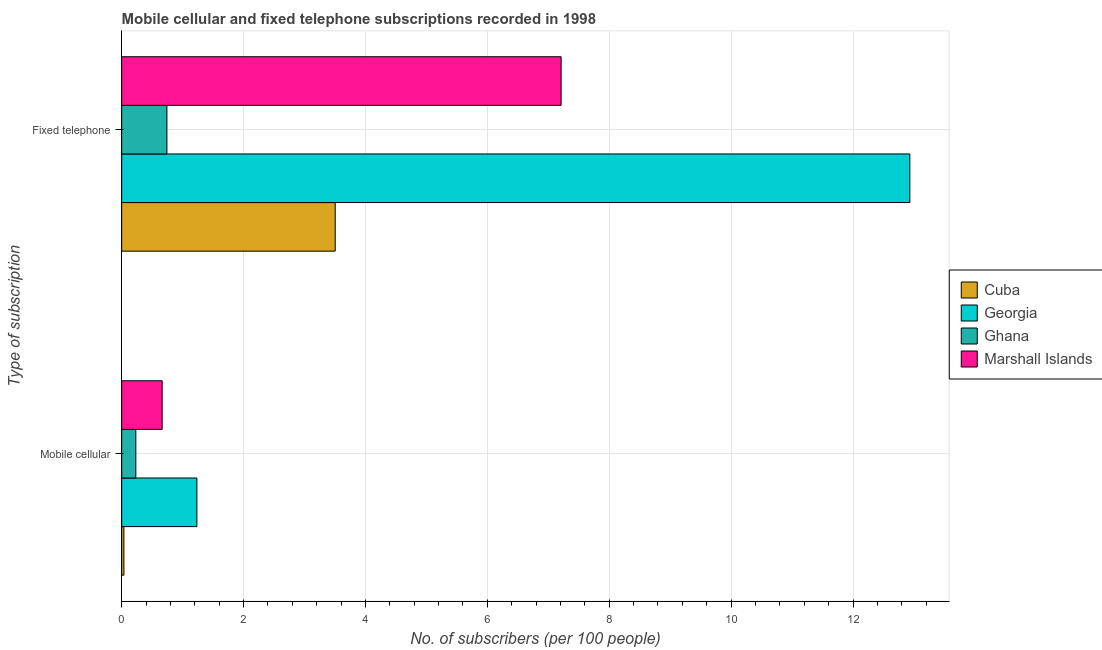How many groups of bars are there?
Your answer should be very brief. 2. Are the number of bars per tick equal to the number of legend labels?
Offer a terse response. Yes. Are the number of bars on each tick of the Y-axis equal?
Make the answer very short. Yes. How many bars are there on the 2nd tick from the top?
Provide a short and direct response. 4. What is the label of the 2nd group of bars from the top?
Make the answer very short. Mobile cellular. What is the number of mobile cellular subscribers in Cuba?
Give a very brief answer. 0.04. Across all countries, what is the maximum number of fixed telephone subscribers?
Ensure brevity in your answer.  12.93. Across all countries, what is the minimum number of fixed telephone subscribers?
Your answer should be very brief. 0.74. In which country was the number of fixed telephone subscribers maximum?
Make the answer very short. Georgia. In which country was the number of fixed telephone subscribers minimum?
Your answer should be very brief. Ghana. What is the total number of fixed telephone subscribers in the graph?
Offer a terse response. 24.39. What is the difference between the number of mobile cellular subscribers in Ghana and that in Marshall Islands?
Offer a very short reply. -0.43. What is the difference between the number of fixed telephone subscribers in Cuba and the number of mobile cellular subscribers in Ghana?
Your answer should be very brief. 3.27. What is the average number of mobile cellular subscribers per country?
Provide a short and direct response. 0.54. What is the difference between the number of fixed telephone subscribers and number of mobile cellular subscribers in Marshall Islands?
Provide a short and direct response. 6.55. What is the ratio of the number of mobile cellular subscribers in Cuba to that in Ghana?
Offer a very short reply. 0.16. Is the number of mobile cellular subscribers in Georgia less than that in Cuba?
Make the answer very short. No. In how many countries, is the number of mobile cellular subscribers greater than the average number of mobile cellular subscribers taken over all countries?
Make the answer very short. 2. What does the 4th bar from the top in Mobile cellular represents?
Provide a succinct answer. Cuba. What does the 1st bar from the bottom in Mobile cellular represents?
Provide a short and direct response. Cuba. How many bars are there?
Provide a succinct answer. 8. What is the difference between two consecutive major ticks on the X-axis?
Provide a short and direct response. 2. Are the values on the major ticks of X-axis written in scientific E-notation?
Your answer should be very brief. No. Does the graph contain grids?
Give a very brief answer. Yes. How many legend labels are there?
Offer a terse response. 4. What is the title of the graph?
Offer a terse response. Mobile cellular and fixed telephone subscriptions recorded in 1998. What is the label or title of the X-axis?
Ensure brevity in your answer.  No. of subscribers (per 100 people). What is the label or title of the Y-axis?
Offer a very short reply. Type of subscription. What is the No. of subscribers (per 100 people) of Cuba in Mobile cellular?
Keep it short and to the point. 0.04. What is the No. of subscribers (per 100 people) in Georgia in Mobile cellular?
Give a very brief answer. 1.23. What is the No. of subscribers (per 100 people) of Ghana in Mobile cellular?
Make the answer very short. 0.23. What is the No. of subscribers (per 100 people) in Marshall Islands in Mobile cellular?
Ensure brevity in your answer.  0.66. What is the No. of subscribers (per 100 people) of Cuba in Fixed telephone?
Provide a short and direct response. 3.5. What is the No. of subscribers (per 100 people) of Georgia in Fixed telephone?
Keep it short and to the point. 12.93. What is the No. of subscribers (per 100 people) in Ghana in Fixed telephone?
Make the answer very short. 0.74. What is the No. of subscribers (per 100 people) in Marshall Islands in Fixed telephone?
Your response must be concise. 7.21. Across all Type of subscription, what is the maximum No. of subscribers (per 100 people) in Cuba?
Your answer should be very brief. 3.5. Across all Type of subscription, what is the maximum No. of subscribers (per 100 people) of Georgia?
Ensure brevity in your answer.  12.93. Across all Type of subscription, what is the maximum No. of subscribers (per 100 people) in Ghana?
Your response must be concise. 0.74. Across all Type of subscription, what is the maximum No. of subscribers (per 100 people) of Marshall Islands?
Your answer should be compact. 7.21. Across all Type of subscription, what is the minimum No. of subscribers (per 100 people) of Cuba?
Give a very brief answer. 0.04. Across all Type of subscription, what is the minimum No. of subscribers (per 100 people) of Georgia?
Keep it short and to the point. 1.23. Across all Type of subscription, what is the minimum No. of subscribers (per 100 people) of Ghana?
Your answer should be very brief. 0.23. Across all Type of subscription, what is the minimum No. of subscribers (per 100 people) in Marshall Islands?
Offer a very short reply. 0.66. What is the total No. of subscribers (per 100 people) of Cuba in the graph?
Ensure brevity in your answer.  3.54. What is the total No. of subscribers (per 100 people) in Georgia in the graph?
Provide a succinct answer. 14.17. What is the total No. of subscribers (per 100 people) of Ghana in the graph?
Your answer should be very brief. 0.97. What is the total No. of subscribers (per 100 people) of Marshall Islands in the graph?
Your response must be concise. 7.88. What is the difference between the No. of subscribers (per 100 people) in Cuba in Mobile cellular and that in Fixed telephone?
Provide a short and direct response. -3.47. What is the difference between the No. of subscribers (per 100 people) in Georgia in Mobile cellular and that in Fixed telephone?
Offer a very short reply. -11.7. What is the difference between the No. of subscribers (per 100 people) in Ghana in Mobile cellular and that in Fixed telephone?
Your answer should be compact. -0.51. What is the difference between the No. of subscribers (per 100 people) of Marshall Islands in Mobile cellular and that in Fixed telephone?
Your answer should be very brief. -6.55. What is the difference between the No. of subscribers (per 100 people) of Cuba in Mobile cellular and the No. of subscribers (per 100 people) of Georgia in Fixed telephone?
Offer a terse response. -12.9. What is the difference between the No. of subscribers (per 100 people) of Cuba in Mobile cellular and the No. of subscribers (per 100 people) of Ghana in Fixed telephone?
Your answer should be very brief. -0.71. What is the difference between the No. of subscribers (per 100 people) of Cuba in Mobile cellular and the No. of subscribers (per 100 people) of Marshall Islands in Fixed telephone?
Provide a short and direct response. -7.17. What is the difference between the No. of subscribers (per 100 people) of Georgia in Mobile cellular and the No. of subscribers (per 100 people) of Ghana in Fixed telephone?
Ensure brevity in your answer.  0.49. What is the difference between the No. of subscribers (per 100 people) in Georgia in Mobile cellular and the No. of subscribers (per 100 people) in Marshall Islands in Fixed telephone?
Keep it short and to the point. -5.98. What is the difference between the No. of subscribers (per 100 people) in Ghana in Mobile cellular and the No. of subscribers (per 100 people) in Marshall Islands in Fixed telephone?
Make the answer very short. -6.98. What is the average No. of subscribers (per 100 people) of Cuba per Type of subscription?
Offer a very short reply. 1.77. What is the average No. of subscribers (per 100 people) in Georgia per Type of subscription?
Offer a terse response. 7.08. What is the average No. of subscribers (per 100 people) in Ghana per Type of subscription?
Offer a very short reply. 0.49. What is the average No. of subscribers (per 100 people) in Marshall Islands per Type of subscription?
Make the answer very short. 3.94. What is the difference between the No. of subscribers (per 100 people) in Cuba and No. of subscribers (per 100 people) in Georgia in Mobile cellular?
Your answer should be compact. -1.2. What is the difference between the No. of subscribers (per 100 people) in Cuba and No. of subscribers (per 100 people) in Ghana in Mobile cellular?
Offer a very short reply. -0.2. What is the difference between the No. of subscribers (per 100 people) of Cuba and No. of subscribers (per 100 people) of Marshall Islands in Mobile cellular?
Offer a very short reply. -0.63. What is the difference between the No. of subscribers (per 100 people) in Georgia and No. of subscribers (per 100 people) in Ghana in Mobile cellular?
Offer a terse response. 1. What is the difference between the No. of subscribers (per 100 people) in Georgia and No. of subscribers (per 100 people) in Marshall Islands in Mobile cellular?
Provide a succinct answer. 0.57. What is the difference between the No. of subscribers (per 100 people) of Ghana and No. of subscribers (per 100 people) of Marshall Islands in Mobile cellular?
Ensure brevity in your answer.  -0.43. What is the difference between the No. of subscribers (per 100 people) of Cuba and No. of subscribers (per 100 people) of Georgia in Fixed telephone?
Offer a very short reply. -9.43. What is the difference between the No. of subscribers (per 100 people) in Cuba and No. of subscribers (per 100 people) in Ghana in Fixed telephone?
Your answer should be compact. 2.76. What is the difference between the No. of subscribers (per 100 people) in Cuba and No. of subscribers (per 100 people) in Marshall Islands in Fixed telephone?
Make the answer very short. -3.71. What is the difference between the No. of subscribers (per 100 people) of Georgia and No. of subscribers (per 100 people) of Ghana in Fixed telephone?
Ensure brevity in your answer.  12.19. What is the difference between the No. of subscribers (per 100 people) in Georgia and No. of subscribers (per 100 people) in Marshall Islands in Fixed telephone?
Keep it short and to the point. 5.72. What is the difference between the No. of subscribers (per 100 people) in Ghana and No. of subscribers (per 100 people) in Marshall Islands in Fixed telephone?
Ensure brevity in your answer.  -6.47. What is the ratio of the No. of subscribers (per 100 people) of Cuba in Mobile cellular to that in Fixed telephone?
Keep it short and to the point. 0.01. What is the ratio of the No. of subscribers (per 100 people) of Georgia in Mobile cellular to that in Fixed telephone?
Provide a short and direct response. 0.1. What is the ratio of the No. of subscribers (per 100 people) of Ghana in Mobile cellular to that in Fixed telephone?
Your response must be concise. 0.31. What is the ratio of the No. of subscribers (per 100 people) of Marshall Islands in Mobile cellular to that in Fixed telephone?
Your response must be concise. 0.09. What is the difference between the highest and the second highest No. of subscribers (per 100 people) of Cuba?
Provide a short and direct response. 3.47. What is the difference between the highest and the second highest No. of subscribers (per 100 people) in Georgia?
Your answer should be compact. 11.7. What is the difference between the highest and the second highest No. of subscribers (per 100 people) of Ghana?
Make the answer very short. 0.51. What is the difference between the highest and the second highest No. of subscribers (per 100 people) in Marshall Islands?
Make the answer very short. 6.55. What is the difference between the highest and the lowest No. of subscribers (per 100 people) in Cuba?
Keep it short and to the point. 3.47. What is the difference between the highest and the lowest No. of subscribers (per 100 people) of Georgia?
Give a very brief answer. 11.7. What is the difference between the highest and the lowest No. of subscribers (per 100 people) in Ghana?
Keep it short and to the point. 0.51. What is the difference between the highest and the lowest No. of subscribers (per 100 people) in Marshall Islands?
Your answer should be very brief. 6.55. 